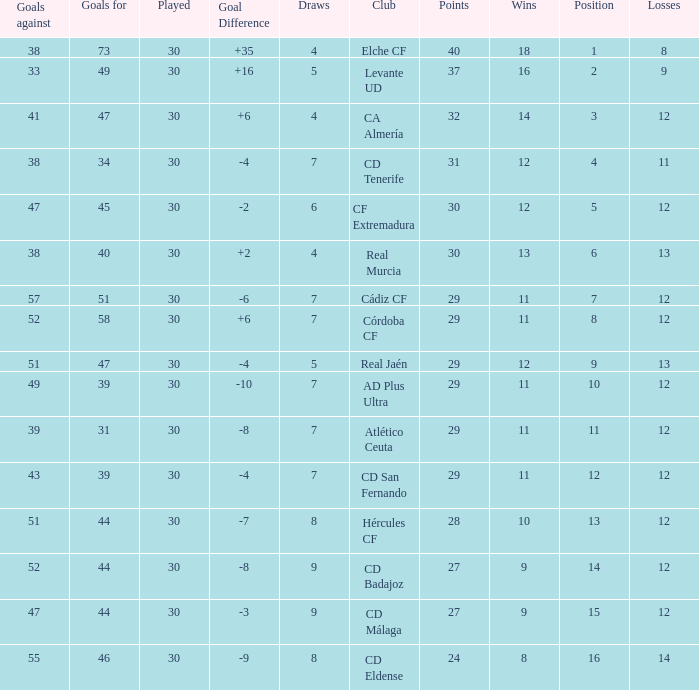What is the total number of losses with less than 73 goals for, less than 11 wins, more than 24 points, and a position greater than 15? 0.0. 